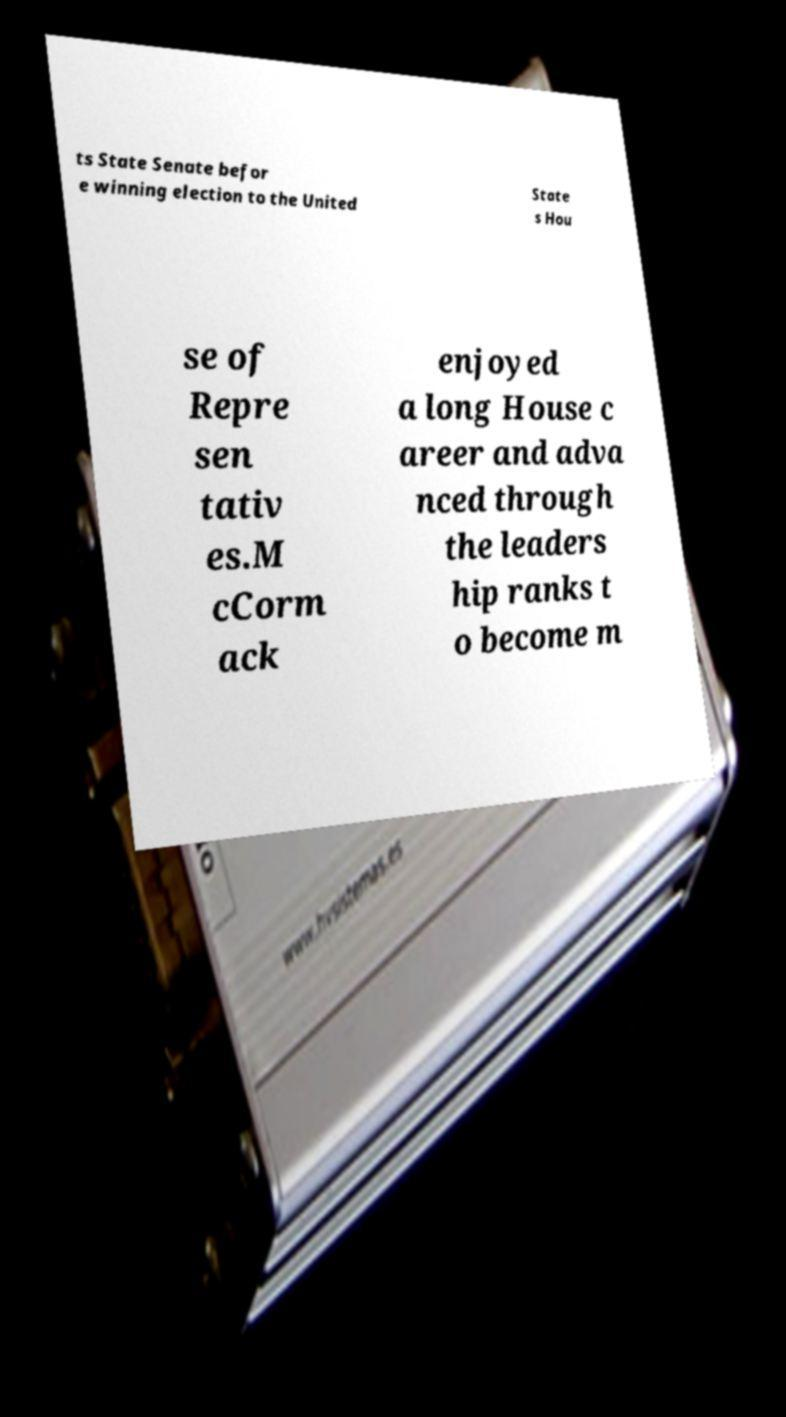I need the written content from this picture converted into text. Can you do that? ts State Senate befor e winning election to the United State s Hou se of Repre sen tativ es.M cCorm ack enjoyed a long House c areer and adva nced through the leaders hip ranks t o become m 